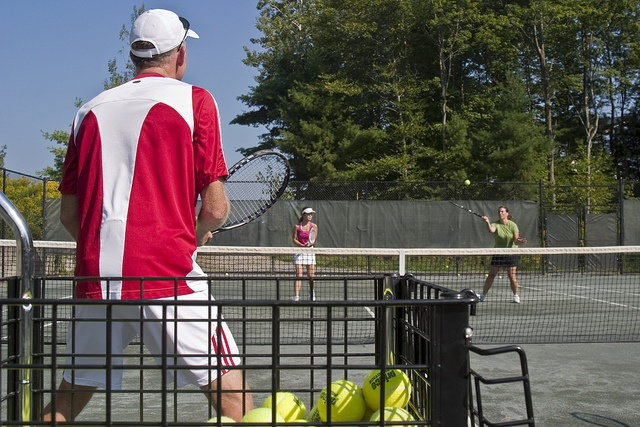Describe the objects in this image and their specific colors. I can see people in gray, lightgray, black, and brown tones, tennis racket in gray, darkgray, and black tones, people in gray, lightgray, darkgray, and black tones, people in gray, black, olive, and darkgreen tones, and sports ball in gray, olive, and khaki tones in this image. 